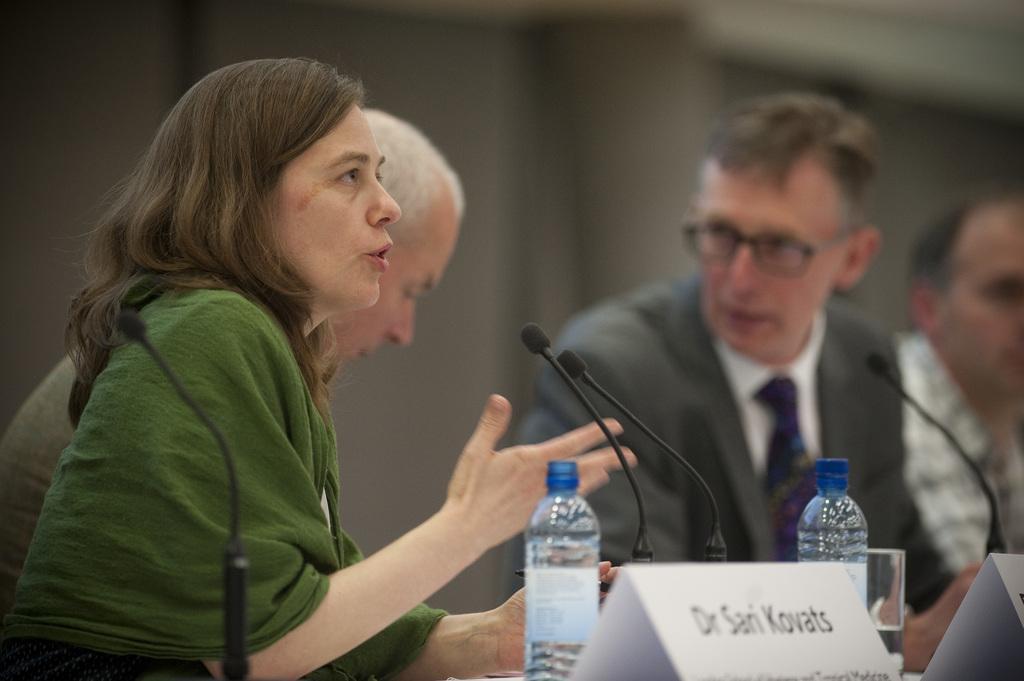Can you describe this image briefly? In this picture we can see four people and in front of them we can see mics, bottles, name boards, glass and in the background it is blurry. 